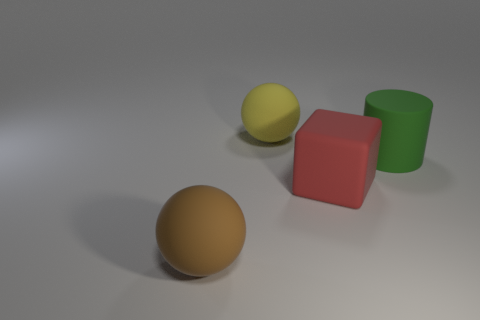What number of big red rubber objects have the same shape as the big yellow matte object?
Make the answer very short. 0. What number of blocks are large purple things or large green matte objects?
Offer a very short reply. 0. Is the shape of the matte object that is on the right side of the large red cube the same as the large rubber thing behind the big green cylinder?
Your answer should be very brief. No. How many yellow things are the same size as the red rubber block?
Your answer should be compact. 1. What number of objects are either large brown matte balls that are in front of the yellow matte thing or things that are behind the green cylinder?
Offer a terse response. 2. What shape is the object on the left side of the matte ball that is behind the big brown sphere?
Make the answer very short. Sphere. Is there anything else of the same color as the big rubber cylinder?
Keep it short and to the point. No. Is there a large green cylinder on the right side of the ball behind the object that is on the left side of the yellow matte sphere?
Keep it short and to the point. Yes. What is the size of the rubber sphere that is behind the big rubber ball that is in front of the thing behind the large green object?
Ensure brevity in your answer.  Large. What number of other objects are the same material as the big red object?
Provide a short and direct response. 3. 